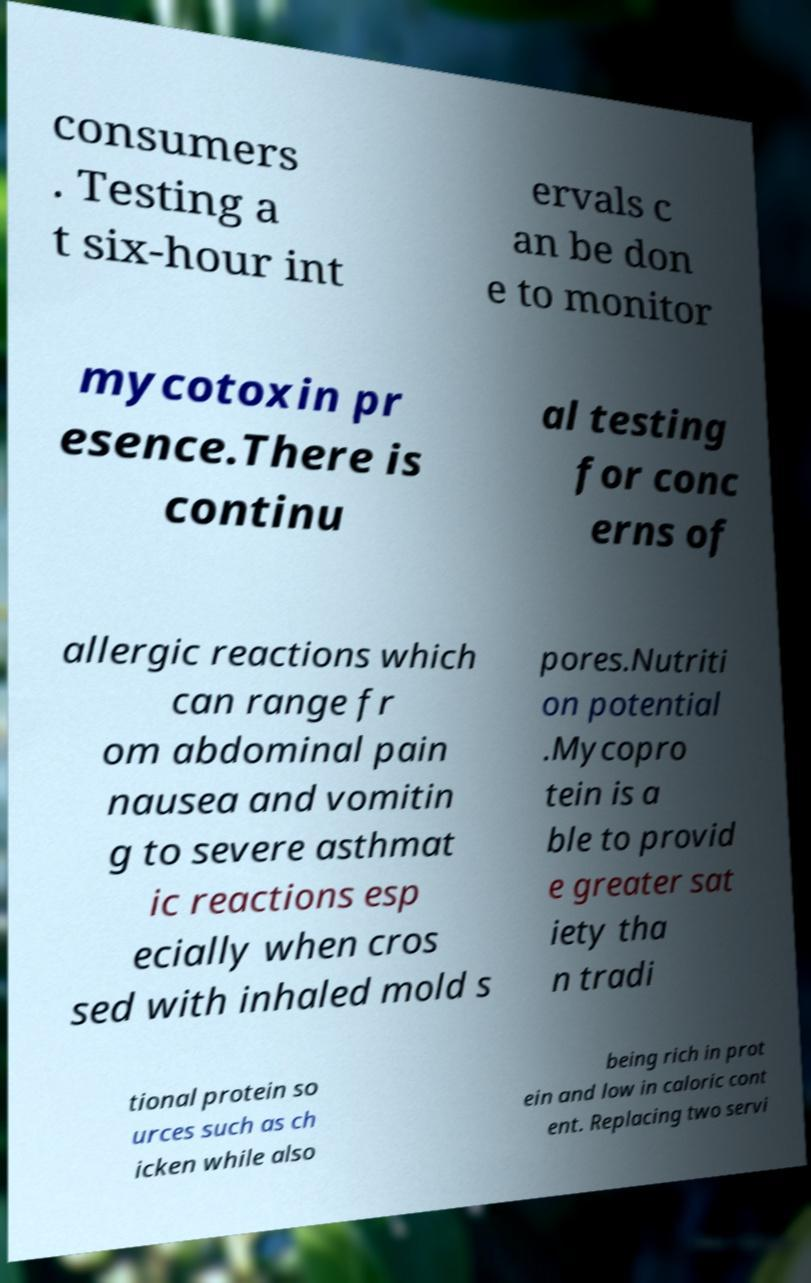Can you read and provide the text displayed in the image?This photo seems to have some interesting text. Can you extract and type it out for me? consumers . Testing a t six-hour int ervals c an be don e to monitor mycotoxin pr esence.There is continu al testing for conc erns of allergic reactions which can range fr om abdominal pain nausea and vomitin g to severe asthmat ic reactions esp ecially when cros sed with inhaled mold s pores.Nutriti on potential .Mycopro tein is a ble to provid e greater sat iety tha n tradi tional protein so urces such as ch icken while also being rich in prot ein and low in caloric cont ent. Replacing two servi 